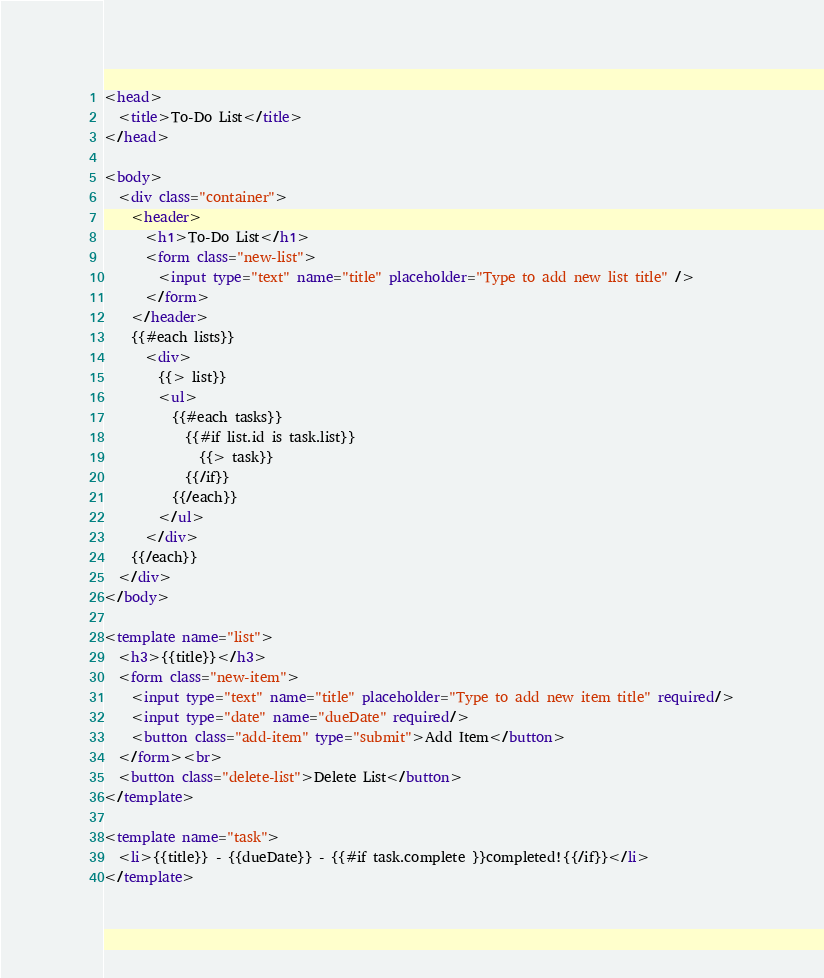Convert code to text. <code><loc_0><loc_0><loc_500><loc_500><_HTML_><head>
  <title>To-Do List</title>
</head>

<body>
  <div class="container">
    <header>
      <h1>To-Do List</h1>
      <form class="new-list">
        <input type="text" name="title" placeholder="Type to add new list title" />
      </form>
    </header>
    {{#each lists}}
      <div>
        {{> list}}
        <ul>
          {{#each tasks}}
            {{#if list.id is task.list}}
              {{> task}}
            {{/if}}
          {{/each}}
        </ul>
      </div>
    {{/each}}
  </div>
</body>

<template name="list">
  <h3>{{title}}</h3>
  <form class="new-item">
    <input type="text" name="title" placeholder="Type to add new item title" required/>
    <input type="date" name="dueDate" required/>
    <button class="add-item" type="submit">Add Item</button>
  </form><br>
  <button class="delete-list">Delete List</button>
</template>

<template name="task">
  <li>{{title}} - {{dueDate}} - {{#if task.complete }}completed!{{/if}}</li>
</template>
</code> 